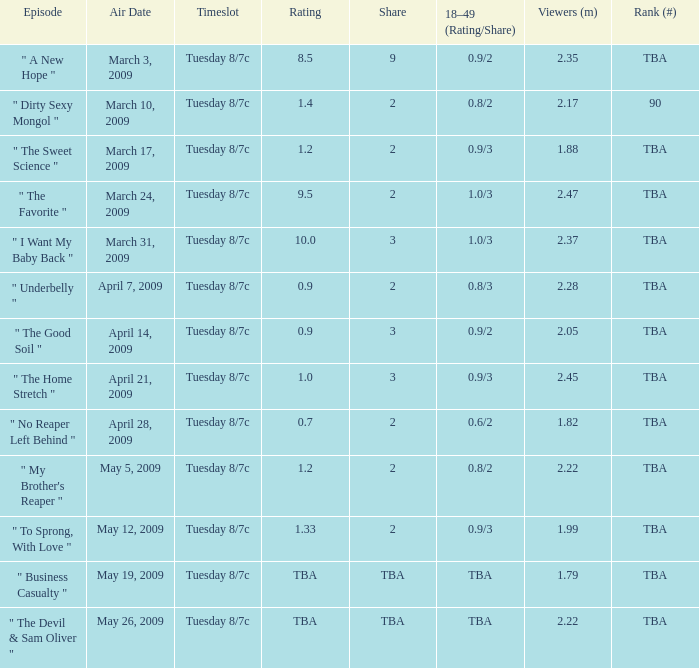For the show ranked tba and aired on the 21st of april, 2009, what is its rating? 1.0. Write the full table. {'header': ['Episode', 'Air Date', 'Timeslot', 'Rating', 'Share', '18–49 (Rating/Share)', 'Viewers (m)', 'Rank (#)'], 'rows': [['" A New Hope "', 'March 3, 2009', 'Tuesday 8/7c', '8.5', '9', '0.9/2', '2.35', 'TBA'], ['" Dirty Sexy Mongol "', 'March 10, 2009', 'Tuesday 8/7c', '1.4', '2', '0.8/2', '2.17', '90'], ['" The Sweet Science "', 'March 17, 2009', 'Tuesday 8/7c', '1.2', '2', '0.9/3', '1.88', 'TBA'], ['" The Favorite "', 'March 24, 2009', 'Tuesday 8/7c', '9.5', '2', '1.0/3', '2.47', 'TBA'], ['" I Want My Baby Back "', 'March 31, 2009', 'Tuesday 8/7c', '10.0', '3', '1.0/3', '2.37', 'TBA'], ['" Underbelly "', 'April 7, 2009', 'Tuesday 8/7c', '0.9', '2', '0.8/3', '2.28', 'TBA'], ['" The Good Soil "', 'April 14, 2009', 'Tuesday 8/7c', '0.9', '3', '0.9/2', '2.05', 'TBA'], ['" The Home Stretch "', 'April 21, 2009', 'Tuesday 8/7c', '1.0', '3', '0.9/3', '2.45', 'TBA'], ['" No Reaper Left Behind "', 'April 28, 2009', 'Tuesday 8/7c', '0.7', '2', '0.6/2', '1.82', 'TBA'], ['" My Brother\'s Reaper "', 'May 5, 2009', 'Tuesday 8/7c', '1.2', '2', '0.8/2', '2.22', 'TBA'], ['" To Sprong, With Love "', 'May 12, 2009', 'Tuesday 8/7c', '1.33', '2', '0.9/3', '1.99', 'TBA'], ['" Business Casualty "', 'May 19, 2009', 'Tuesday 8/7c', 'TBA', 'TBA', 'TBA', '1.79', 'TBA'], ['" The Devil & Sam Oliver "', 'May 26, 2009', 'Tuesday 8/7c', 'TBA', 'TBA', 'TBA', '2.22', 'TBA']]} 